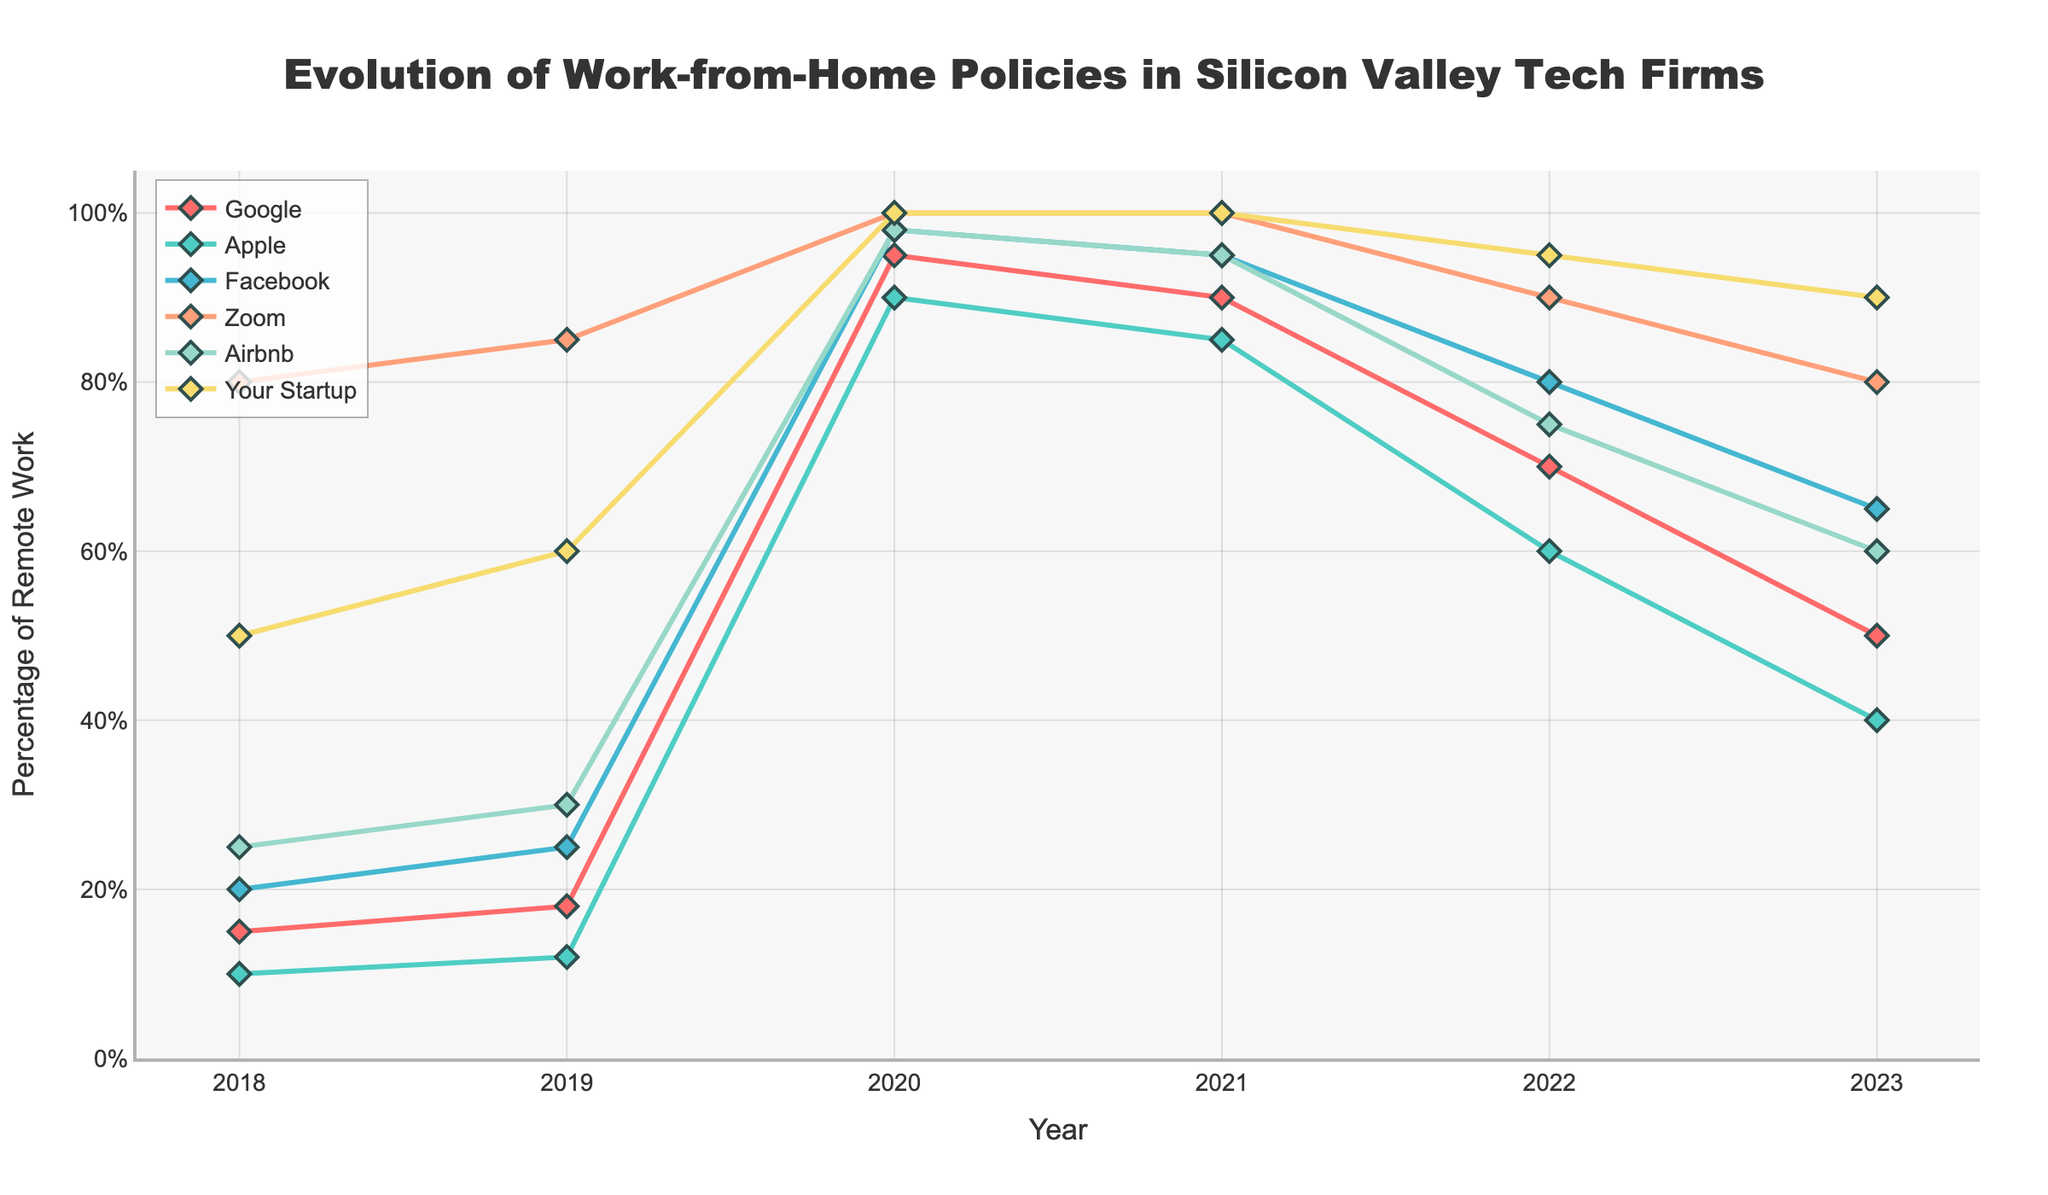What was the percentage of remote work for Google in 2020? We can look at the data point for Google in the year 2020 on the line chart to find the percentage of remote work.
Answer: 95 Which company had the highest percentage of remote work in 2018? By visually inspecting the plot for the year 2018, we can see that Zoom had the highest percentage of remote work.
Answer: Zoom How did the remote work policy for Apple change from 2019 to 2021? By checking the line corresponding to Apple from 2019 to 2021, we can observe the change in the percentage of remote work: 12% in 2019, 90% in 2020, and 85% in 2021.
Answer: Increased from 12% to 90% and then decreased to 85% Which companies had a decrease in the percentage of remote work from 2021 to 2023? We can look for lines that show a downward trend from 2021 to 2023. Google, Apple, Facebook, Zoom, and Airbnb all show a decrease.
Answer: Google, Apple, Facebook, Zoom, Airbnb What is the average percentage of remote work for Facebook across all years? We'll take the percentages for Facebook from each year (20, 25, 98, 95, 80, 65), add them together, and divide by the number of years (6): (20 + 25 + 98 + 95 + 80 + 65) / 6 = 63.83 (approx.).
Answer: 63.83 In which year did Zoom have 100% remote work, and what other company also had close to 100% remote work that year? From the chart, we see that Zoom had 100% remote work in 2020 and 2021. We then look at those years to find that Facebook had 98% and 95% respectively, very close to 100%.
Answer: 2020 and 2021; Facebook What is the total increase in remote work percentage for Your Startup from 2018 to 2023? The percentage for Your Startup in 2018 is 50%, and in 2023 it's 90%. The increase is 90% - 50% = 40%.
Answer: 40% Which company had the smallest change in remote work percentage from 2019 to 2023? By calculating the difference for each company from 2019 to 2023, we see: Google (18% to 50% -> +32%), Apple (12% to 40% -> +28%), Facebook (25% to 65% -> +40%), Zoom (85% to 80% -> -5%), Airbnb (30% to 60% -> +30%), Your Startup (60% to 90% -> +30%). The smallest change is for Zoom with -5%.
Answer: Zoom What is the trend in remote work percentage for Airbnb from 2020 to 2023? Observing the chart, we see the remote work percentage for Airbnb decreasing over the years: from 98% in 2020 to 75% in 2022, and further to 60% in 2023.
Answer: Decreasing 